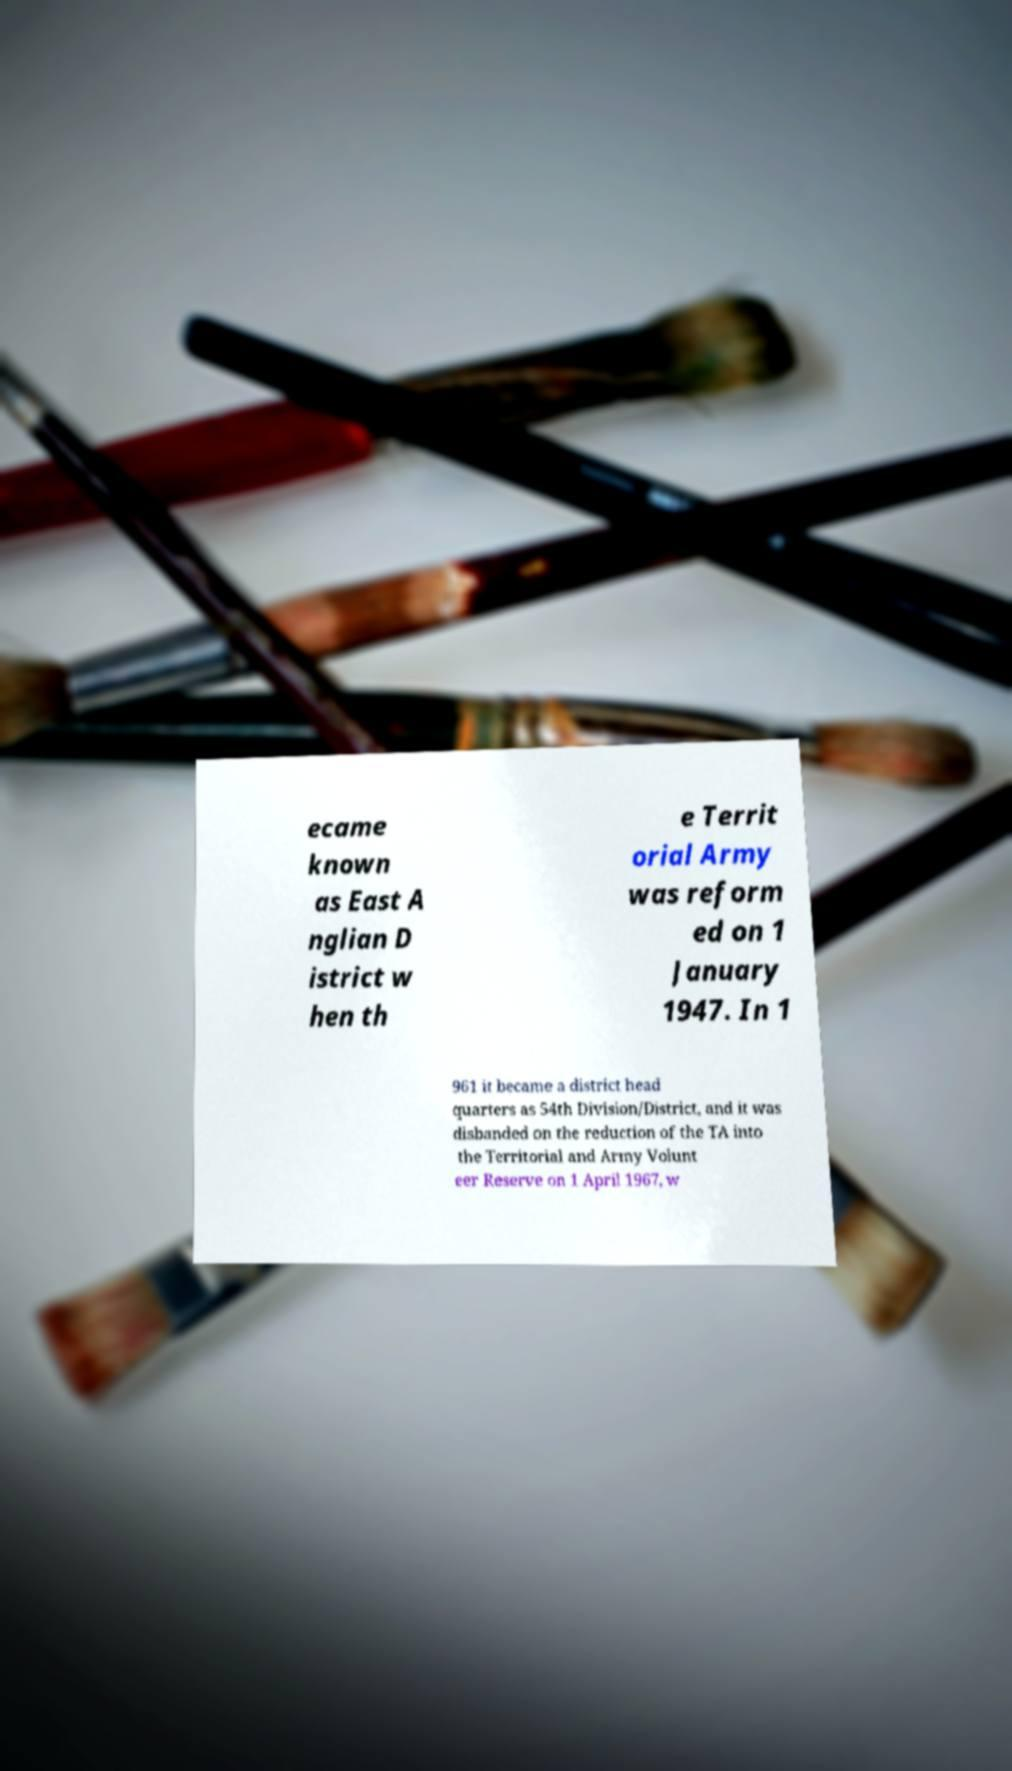Could you assist in decoding the text presented in this image and type it out clearly? ecame known as East A nglian D istrict w hen th e Territ orial Army was reform ed on 1 January 1947. In 1 961 it became a district head quarters as 54th Division/District, and it was disbanded on the reduction of the TA into the Territorial and Army Volunt eer Reserve on 1 April 1967, w 